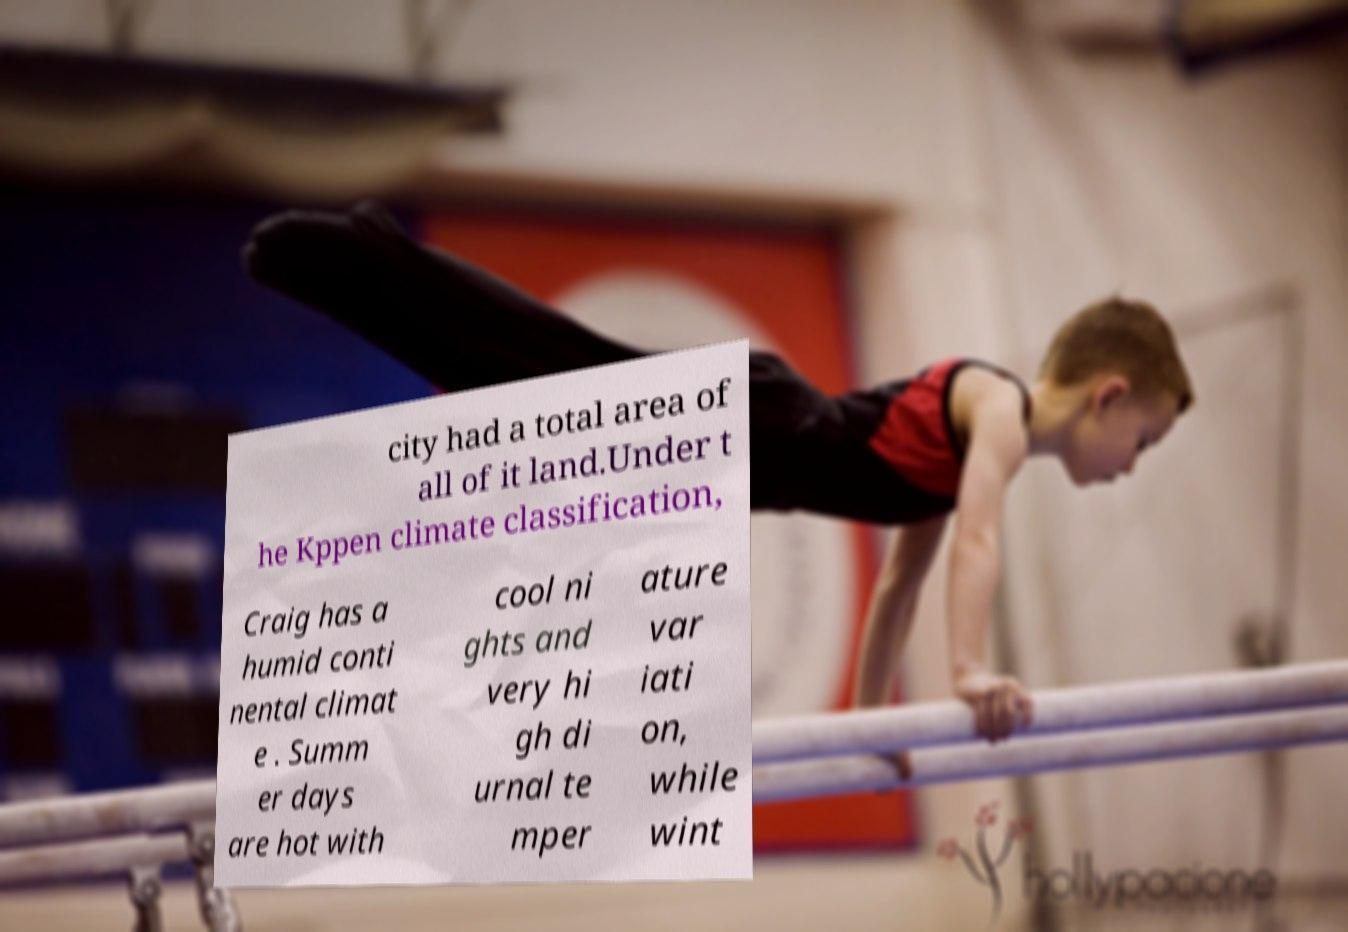Could you assist in decoding the text presented in this image and type it out clearly? city had a total area of all of it land.Under t he Kppen climate classification, Craig has a humid conti nental climat e . Summ er days are hot with cool ni ghts and very hi gh di urnal te mper ature var iati on, while wint 